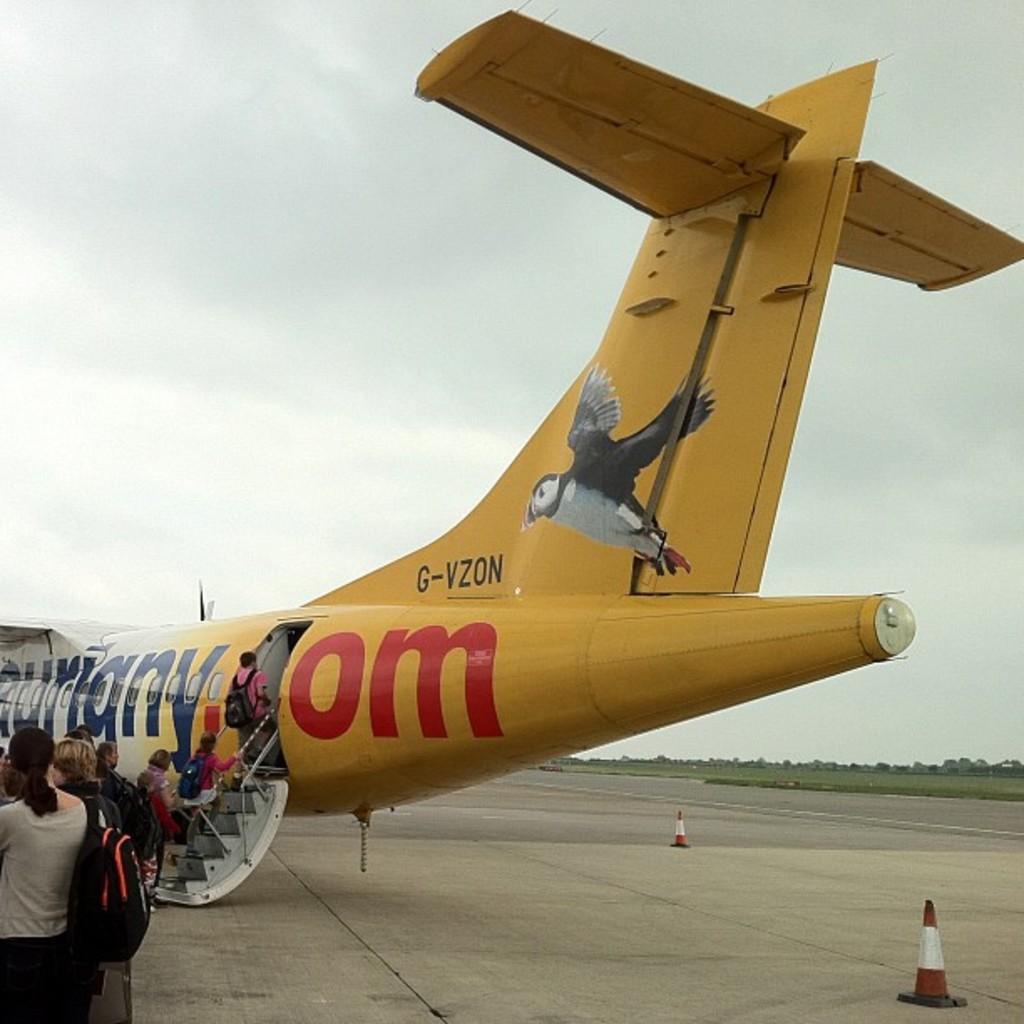In one or two sentences, can you explain what this image depicts? In this image in the center there is an airplane, and some people are walking into airplane and some of them are standing. And there are some barricades, and in the background there are some trees and grass. At the top there is sky. 